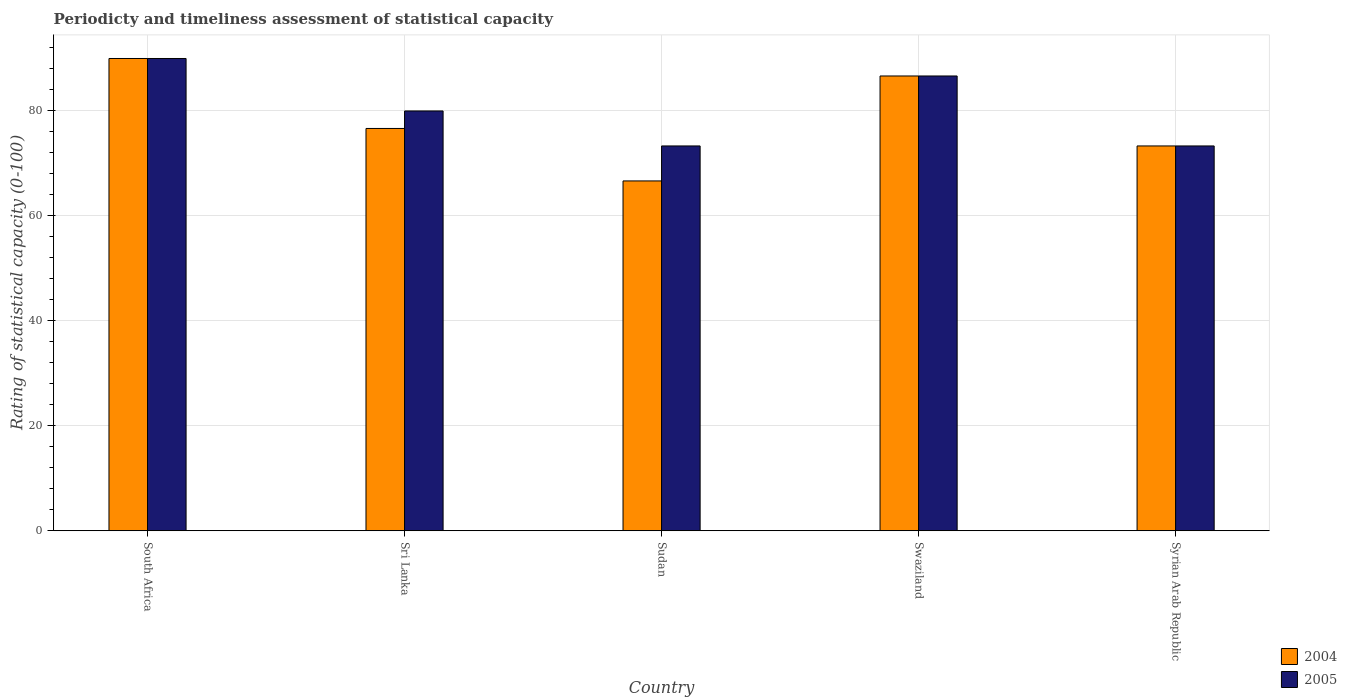Are the number of bars per tick equal to the number of legend labels?
Your response must be concise. Yes. Are the number of bars on each tick of the X-axis equal?
Keep it short and to the point. Yes. How many bars are there on the 2nd tick from the right?
Your answer should be compact. 2. What is the label of the 4th group of bars from the left?
Offer a very short reply. Swaziland. In how many cases, is the number of bars for a given country not equal to the number of legend labels?
Your answer should be very brief. 0. What is the rating of statistical capacity in 2004 in Sudan?
Your response must be concise. 66.67. Across all countries, what is the maximum rating of statistical capacity in 2005?
Offer a very short reply. 90. Across all countries, what is the minimum rating of statistical capacity in 2004?
Keep it short and to the point. 66.67. In which country was the rating of statistical capacity in 2005 maximum?
Make the answer very short. South Africa. In which country was the rating of statistical capacity in 2005 minimum?
Offer a very short reply. Sudan. What is the total rating of statistical capacity in 2004 in the graph?
Keep it short and to the point. 393.33. What is the difference between the rating of statistical capacity in 2004 in Sri Lanka and that in Syrian Arab Republic?
Provide a succinct answer. 3.33. What is the difference between the rating of statistical capacity in 2005 in Sri Lanka and the rating of statistical capacity in 2004 in Sudan?
Offer a very short reply. 13.33. What is the average rating of statistical capacity in 2004 per country?
Ensure brevity in your answer.  78.67. What is the ratio of the rating of statistical capacity in 2005 in Sri Lanka to that in Syrian Arab Republic?
Offer a very short reply. 1.09. What is the difference between the highest and the lowest rating of statistical capacity in 2004?
Keep it short and to the point. 23.33. In how many countries, is the rating of statistical capacity in 2004 greater than the average rating of statistical capacity in 2004 taken over all countries?
Offer a terse response. 2. Is the sum of the rating of statistical capacity in 2005 in Sri Lanka and Syrian Arab Republic greater than the maximum rating of statistical capacity in 2004 across all countries?
Offer a terse response. Yes. What does the 2nd bar from the left in Syrian Arab Republic represents?
Your response must be concise. 2005. How many bars are there?
Offer a terse response. 10. How many countries are there in the graph?
Provide a succinct answer. 5. What is the difference between two consecutive major ticks on the Y-axis?
Make the answer very short. 20. Are the values on the major ticks of Y-axis written in scientific E-notation?
Offer a very short reply. No. Does the graph contain any zero values?
Give a very brief answer. No. What is the title of the graph?
Offer a very short reply. Periodicty and timeliness assessment of statistical capacity. What is the label or title of the X-axis?
Ensure brevity in your answer.  Country. What is the label or title of the Y-axis?
Give a very brief answer. Rating of statistical capacity (0-100). What is the Rating of statistical capacity (0-100) of 2004 in South Africa?
Offer a terse response. 90. What is the Rating of statistical capacity (0-100) in 2004 in Sri Lanka?
Offer a terse response. 76.67. What is the Rating of statistical capacity (0-100) of 2004 in Sudan?
Offer a very short reply. 66.67. What is the Rating of statistical capacity (0-100) of 2005 in Sudan?
Your response must be concise. 73.33. What is the Rating of statistical capacity (0-100) in 2004 in Swaziland?
Keep it short and to the point. 86.67. What is the Rating of statistical capacity (0-100) of 2005 in Swaziland?
Ensure brevity in your answer.  86.67. What is the Rating of statistical capacity (0-100) of 2004 in Syrian Arab Republic?
Ensure brevity in your answer.  73.33. What is the Rating of statistical capacity (0-100) in 2005 in Syrian Arab Republic?
Your response must be concise. 73.33. Across all countries, what is the minimum Rating of statistical capacity (0-100) of 2004?
Offer a terse response. 66.67. Across all countries, what is the minimum Rating of statistical capacity (0-100) in 2005?
Provide a short and direct response. 73.33. What is the total Rating of statistical capacity (0-100) in 2004 in the graph?
Your answer should be compact. 393.33. What is the total Rating of statistical capacity (0-100) in 2005 in the graph?
Your answer should be compact. 403.33. What is the difference between the Rating of statistical capacity (0-100) in 2004 in South Africa and that in Sri Lanka?
Keep it short and to the point. 13.33. What is the difference between the Rating of statistical capacity (0-100) in 2005 in South Africa and that in Sri Lanka?
Give a very brief answer. 10. What is the difference between the Rating of statistical capacity (0-100) in 2004 in South Africa and that in Sudan?
Give a very brief answer. 23.33. What is the difference between the Rating of statistical capacity (0-100) of 2005 in South Africa and that in Sudan?
Your response must be concise. 16.67. What is the difference between the Rating of statistical capacity (0-100) in 2004 in South Africa and that in Syrian Arab Republic?
Make the answer very short. 16.67. What is the difference between the Rating of statistical capacity (0-100) in 2005 in South Africa and that in Syrian Arab Republic?
Provide a succinct answer. 16.67. What is the difference between the Rating of statistical capacity (0-100) in 2004 in Sri Lanka and that in Sudan?
Offer a terse response. 10. What is the difference between the Rating of statistical capacity (0-100) in 2004 in Sri Lanka and that in Swaziland?
Your answer should be compact. -10. What is the difference between the Rating of statistical capacity (0-100) in 2005 in Sri Lanka and that in Swaziland?
Offer a terse response. -6.67. What is the difference between the Rating of statistical capacity (0-100) in 2004 in Sudan and that in Swaziland?
Your response must be concise. -20. What is the difference between the Rating of statistical capacity (0-100) of 2005 in Sudan and that in Swaziland?
Give a very brief answer. -13.33. What is the difference between the Rating of statistical capacity (0-100) in 2004 in Sudan and that in Syrian Arab Republic?
Offer a very short reply. -6.67. What is the difference between the Rating of statistical capacity (0-100) of 2005 in Sudan and that in Syrian Arab Republic?
Offer a terse response. 0. What is the difference between the Rating of statistical capacity (0-100) in 2004 in Swaziland and that in Syrian Arab Republic?
Give a very brief answer. 13.33. What is the difference between the Rating of statistical capacity (0-100) of 2005 in Swaziland and that in Syrian Arab Republic?
Provide a short and direct response. 13.33. What is the difference between the Rating of statistical capacity (0-100) of 2004 in South Africa and the Rating of statistical capacity (0-100) of 2005 in Sudan?
Make the answer very short. 16.67. What is the difference between the Rating of statistical capacity (0-100) in 2004 in South Africa and the Rating of statistical capacity (0-100) in 2005 in Swaziland?
Your response must be concise. 3.33. What is the difference between the Rating of statistical capacity (0-100) in 2004 in South Africa and the Rating of statistical capacity (0-100) in 2005 in Syrian Arab Republic?
Provide a succinct answer. 16.67. What is the difference between the Rating of statistical capacity (0-100) of 2004 in Sri Lanka and the Rating of statistical capacity (0-100) of 2005 in Syrian Arab Republic?
Make the answer very short. 3.33. What is the difference between the Rating of statistical capacity (0-100) in 2004 in Sudan and the Rating of statistical capacity (0-100) in 2005 in Swaziland?
Keep it short and to the point. -20. What is the difference between the Rating of statistical capacity (0-100) of 2004 in Sudan and the Rating of statistical capacity (0-100) of 2005 in Syrian Arab Republic?
Make the answer very short. -6.67. What is the difference between the Rating of statistical capacity (0-100) of 2004 in Swaziland and the Rating of statistical capacity (0-100) of 2005 in Syrian Arab Republic?
Provide a short and direct response. 13.33. What is the average Rating of statistical capacity (0-100) in 2004 per country?
Offer a very short reply. 78.67. What is the average Rating of statistical capacity (0-100) of 2005 per country?
Give a very brief answer. 80.67. What is the difference between the Rating of statistical capacity (0-100) in 2004 and Rating of statistical capacity (0-100) in 2005 in Sudan?
Offer a very short reply. -6.67. What is the ratio of the Rating of statistical capacity (0-100) in 2004 in South Africa to that in Sri Lanka?
Your answer should be compact. 1.17. What is the ratio of the Rating of statistical capacity (0-100) in 2004 in South Africa to that in Sudan?
Provide a short and direct response. 1.35. What is the ratio of the Rating of statistical capacity (0-100) of 2005 in South Africa to that in Sudan?
Provide a succinct answer. 1.23. What is the ratio of the Rating of statistical capacity (0-100) in 2004 in South Africa to that in Swaziland?
Your answer should be compact. 1.04. What is the ratio of the Rating of statistical capacity (0-100) of 2005 in South Africa to that in Swaziland?
Your answer should be very brief. 1.04. What is the ratio of the Rating of statistical capacity (0-100) in 2004 in South Africa to that in Syrian Arab Republic?
Your answer should be very brief. 1.23. What is the ratio of the Rating of statistical capacity (0-100) in 2005 in South Africa to that in Syrian Arab Republic?
Offer a terse response. 1.23. What is the ratio of the Rating of statistical capacity (0-100) of 2004 in Sri Lanka to that in Sudan?
Your answer should be compact. 1.15. What is the ratio of the Rating of statistical capacity (0-100) of 2005 in Sri Lanka to that in Sudan?
Ensure brevity in your answer.  1.09. What is the ratio of the Rating of statistical capacity (0-100) in 2004 in Sri Lanka to that in Swaziland?
Your answer should be very brief. 0.88. What is the ratio of the Rating of statistical capacity (0-100) of 2005 in Sri Lanka to that in Swaziland?
Your answer should be very brief. 0.92. What is the ratio of the Rating of statistical capacity (0-100) in 2004 in Sri Lanka to that in Syrian Arab Republic?
Make the answer very short. 1.05. What is the ratio of the Rating of statistical capacity (0-100) of 2004 in Sudan to that in Swaziland?
Give a very brief answer. 0.77. What is the ratio of the Rating of statistical capacity (0-100) of 2005 in Sudan to that in Swaziland?
Your answer should be compact. 0.85. What is the ratio of the Rating of statistical capacity (0-100) in 2004 in Sudan to that in Syrian Arab Republic?
Offer a terse response. 0.91. What is the ratio of the Rating of statistical capacity (0-100) of 2004 in Swaziland to that in Syrian Arab Republic?
Offer a very short reply. 1.18. What is the ratio of the Rating of statistical capacity (0-100) in 2005 in Swaziland to that in Syrian Arab Republic?
Offer a very short reply. 1.18. What is the difference between the highest and the second highest Rating of statistical capacity (0-100) in 2004?
Ensure brevity in your answer.  3.33. What is the difference between the highest and the second highest Rating of statistical capacity (0-100) of 2005?
Your response must be concise. 3.33. What is the difference between the highest and the lowest Rating of statistical capacity (0-100) in 2004?
Provide a succinct answer. 23.33. What is the difference between the highest and the lowest Rating of statistical capacity (0-100) in 2005?
Provide a short and direct response. 16.67. 